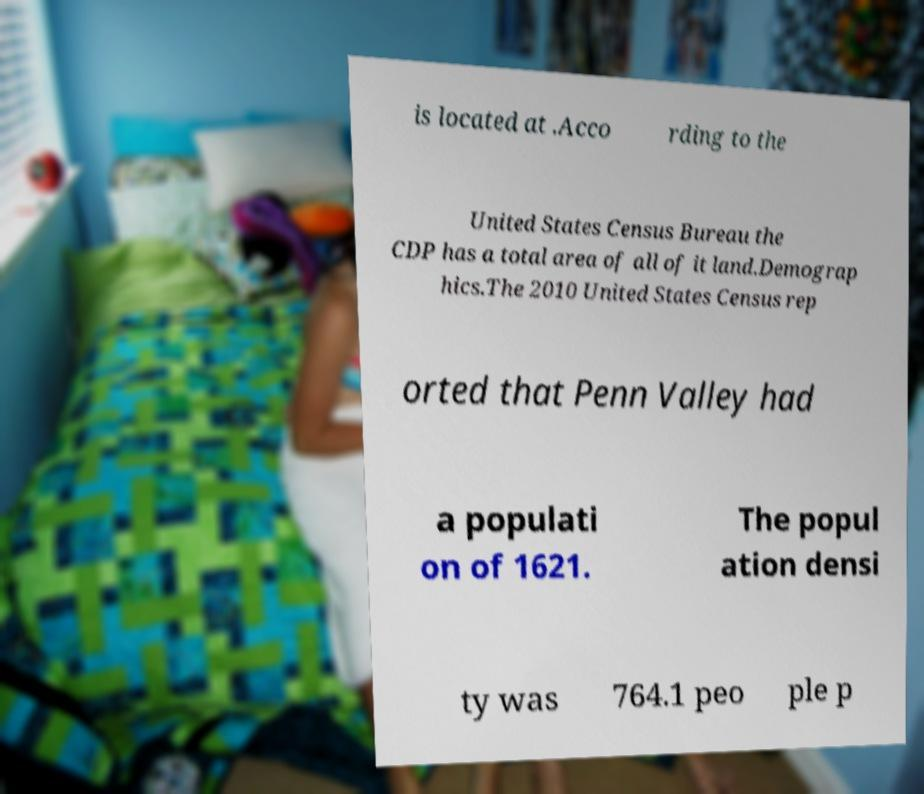For documentation purposes, I need the text within this image transcribed. Could you provide that? is located at .Acco rding to the United States Census Bureau the CDP has a total area of all of it land.Demograp hics.The 2010 United States Census rep orted that Penn Valley had a populati on of 1621. The popul ation densi ty was 764.1 peo ple p 